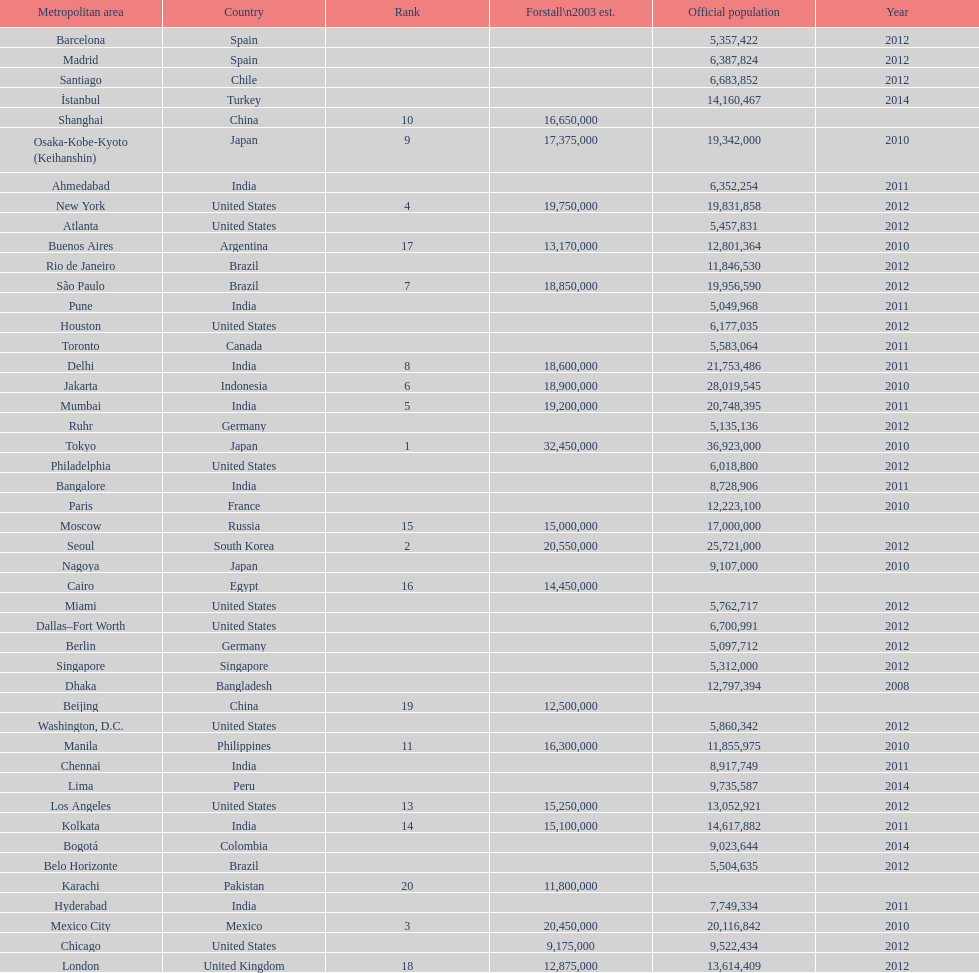In the united states, how many cities are there? 9. 